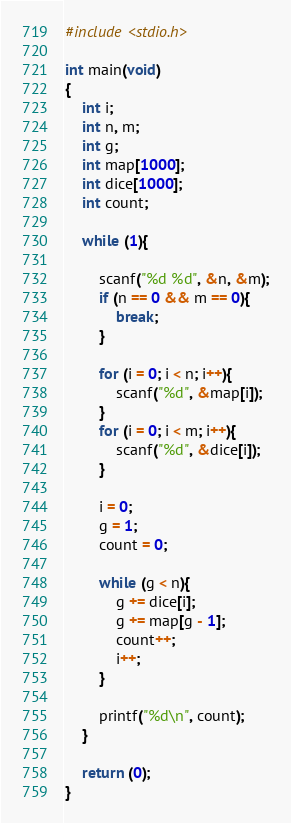Convert code to text. <code><loc_0><loc_0><loc_500><loc_500><_C_>#include <stdio.h>

int main(void)
{
	int i;
	int n, m;
	int g;
	int map[1000];
	int dice[1000];
	int count;

	while (1){

		scanf("%d %d", &n, &m);
		if (n == 0 && m == 0){
			break;
		}

		for (i = 0; i < n; i++){
			scanf("%d", &map[i]);
		}
		for (i = 0; i < m; i++){
			scanf("%d", &dice[i]);
		}

		i = 0;
		g = 1;
		count = 0;

		while (g < n){
			g += dice[i];
			g += map[g - 1];
			count++;
			i++;
		}

		printf("%d\n", count);
	}

	return (0);
}</code> 